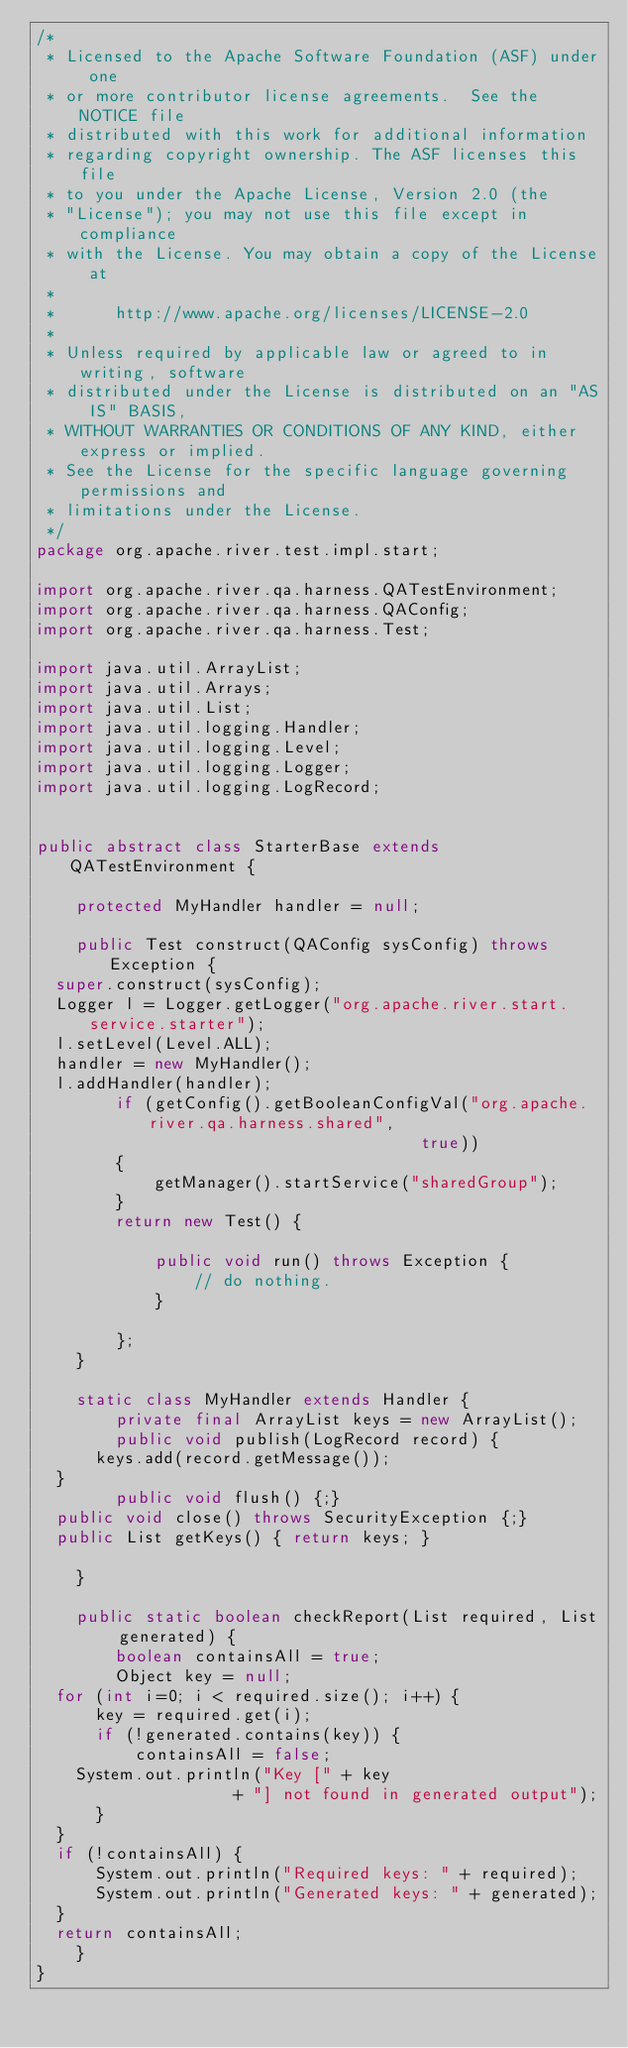<code> <loc_0><loc_0><loc_500><loc_500><_Java_>/*
 * Licensed to the Apache Software Foundation (ASF) under one
 * or more contributor license agreements.  See the NOTICE file
 * distributed with this work for additional information
 * regarding copyright ownership. The ASF licenses this file
 * to you under the Apache License, Version 2.0 (the
 * "License"); you may not use this file except in compliance
 * with the License. You may obtain a copy of the License at
 * 
 *      http://www.apache.org/licenses/LICENSE-2.0
 * 
 * Unless required by applicable law or agreed to in writing, software
 * distributed under the License is distributed on an "AS IS" BASIS,
 * WITHOUT WARRANTIES OR CONDITIONS OF ANY KIND, either express or implied.
 * See the License for the specific language governing permissions and
 * limitations under the License.
 */
package org.apache.river.test.impl.start;

import org.apache.river.qa.harness.QATestEnvironment;
import org.apache.river.qa.harness.QAConfig;
import org.apache.river.qa.harness.Test;

import java.util.ArrayList;
import java.util.Arrays;
import java.util.List;
import java.util.logging.Handler;
import java.util.logging.Level;
import java.util.logging.Logger;
import java.util.logging.LogRecord;


public abstract class StarterBase extends QATestEnvironment {

    protected MyHandler handler = null;

    public Test construct(QAConfig sysConfig) throws Exception {
	super.construct(sysConfig);
	Logger l = Logger.getLogger("org.apache.river.start.service.starter");
	l.setLevel(Level.ALL);
	handler = new MyHandler();
	l.addHandler(handler);
        if (getConfig().getBooleanConfigVal("org.apache.river.qa.harness.shared",
                                       true))
        {
            getManager().startService("sharedGroup");
        }
        return new Test() {

            public void run() throws Exception {
                // do nothing.
            }
            
        };
    }

    static class MyHandler extends Handler {
        private final ArrayList keys = new ArrayList();
        public void publish(LogRecord record) {
	    keys.add(record.getMessage());
	}
        public void flush() {;}
	public void close() throws SecurityException {;}
	public List getKeys() { return keys; }

    }
    
    public static boolean checkReport(List required, List generated) {
        boolean containsAll = true;
        Object key = null;
	for (int i=0; i < required.size(); i++) {
	    key = required.get(i);
	    if (!generated.contains(key)) {
	        containsAll = false;
		System.out.println("Key [" + key 
                    + "] not found in generated output");
	    }
	}
	if (!containsAll) {
	    System.out.println("Required keys: " + required);
	    System.out.println("Generated keys: " + generated);
	}
	return containsAll;
    }
}
</code> 